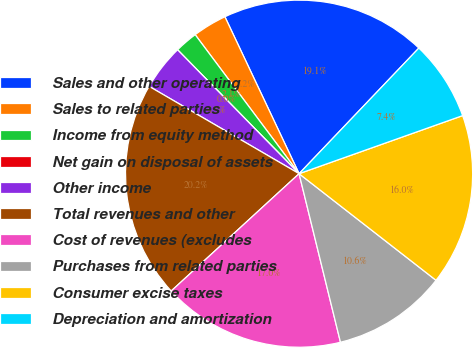Convert chart. <chart><loc_0><loc_0><loc_500><loc_500><pie_chart><fcel>Sales and other operating<fcel>Sales to related parties<fcel>Income from equity method<fcel>Net gain on disposal of assets<fcel>Other income<fcel>Total revenues and other<fcel>Cost of revenues (excludes<fcel>Purchases from related parties<fcel>Consumer excise taxes<fcel>Depreciation and amortization<nl><fcel>19.15%<fcel>3.19%<fcel>2.13%<fcel>0.0%<fcel>4.26%<fcel>20.21%<fcel>17.02%<fcel>10.64%<fcel>15.96%<fcel>7.45%<nl></chart> 